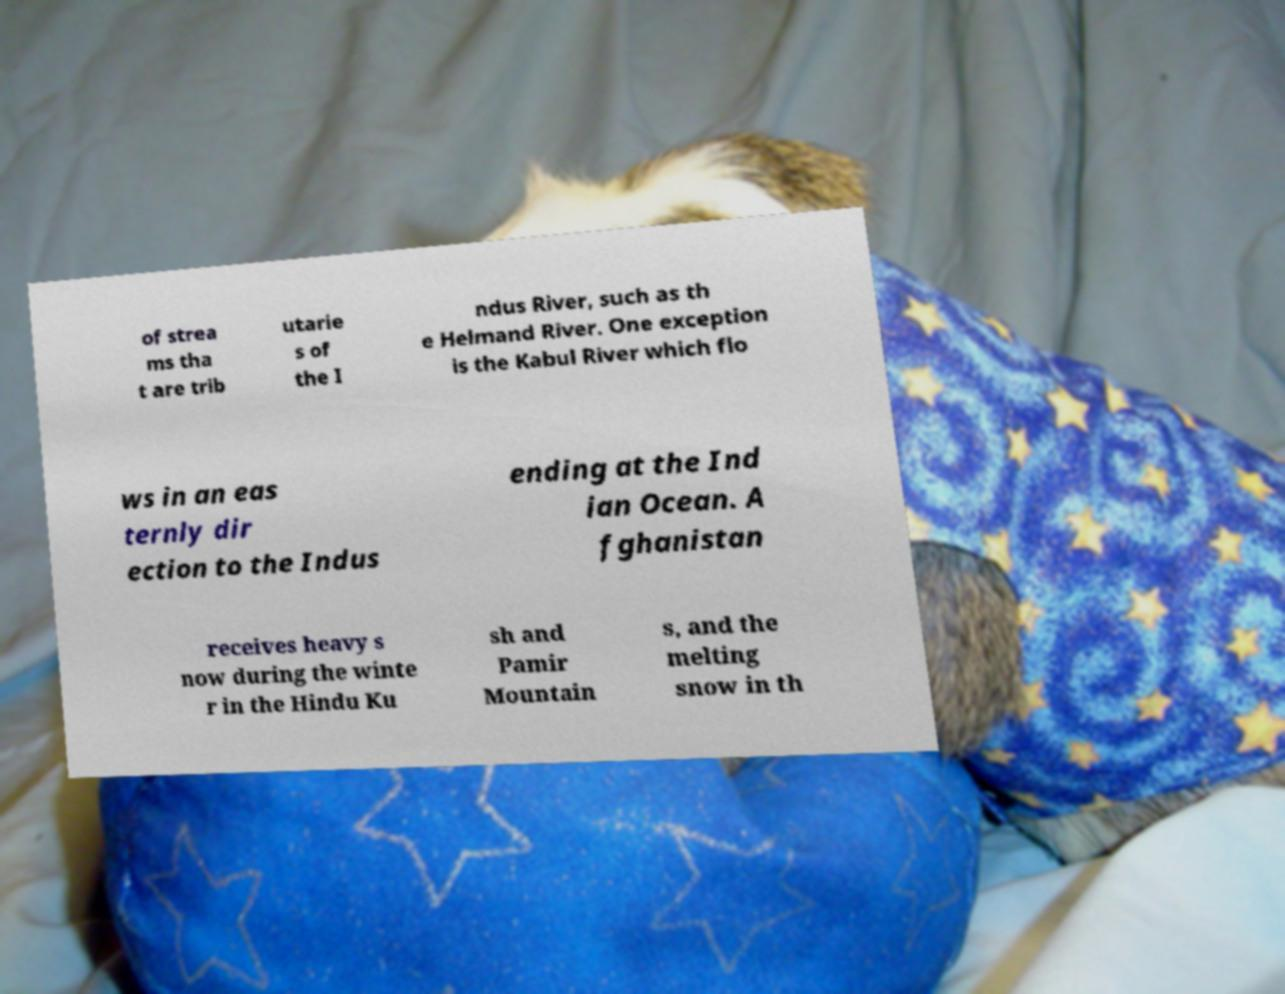Can you read and provide the text displayed in the image?This photo seems to have some interesting text. Can you extract and type it out for me? of strea ms tha t are trib utarie s of the I ndus River, such as th e Helmand River. One exception is the Kabul River which flo ws in an eas ternly dir ection to the Indus ending at the Ind ian Ocean. A fghanistan receives heavy s now during the winte r in the Hindu Ku sh and Pamir Mountain s, and the melting snow in th 